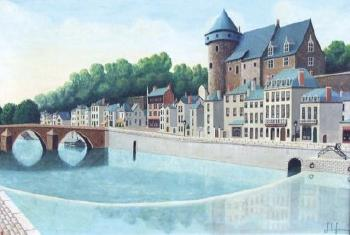Explain the visual content of the image in great detail. The image portrays a picturesque European town, nestled by the side of a serene, light blue river. The town is a charming ensemble of buildings, each unique in its architecture. A castle-like structure stands prominently on the right, adding a touch of grandeur to the scene. The buildings, painted in hues of white, beige, and red, lend a warm and inviting atmosphere to the town. Two bridges arch gracefully over the river, connecting the different parts of the town. The art style is realistic, capturing the intricate details of the town and its surroundings with precision. The genre of the painting can be identified as landscape or cityscape, as it beautifully encapsulates the essence of the town and its natural setting. 